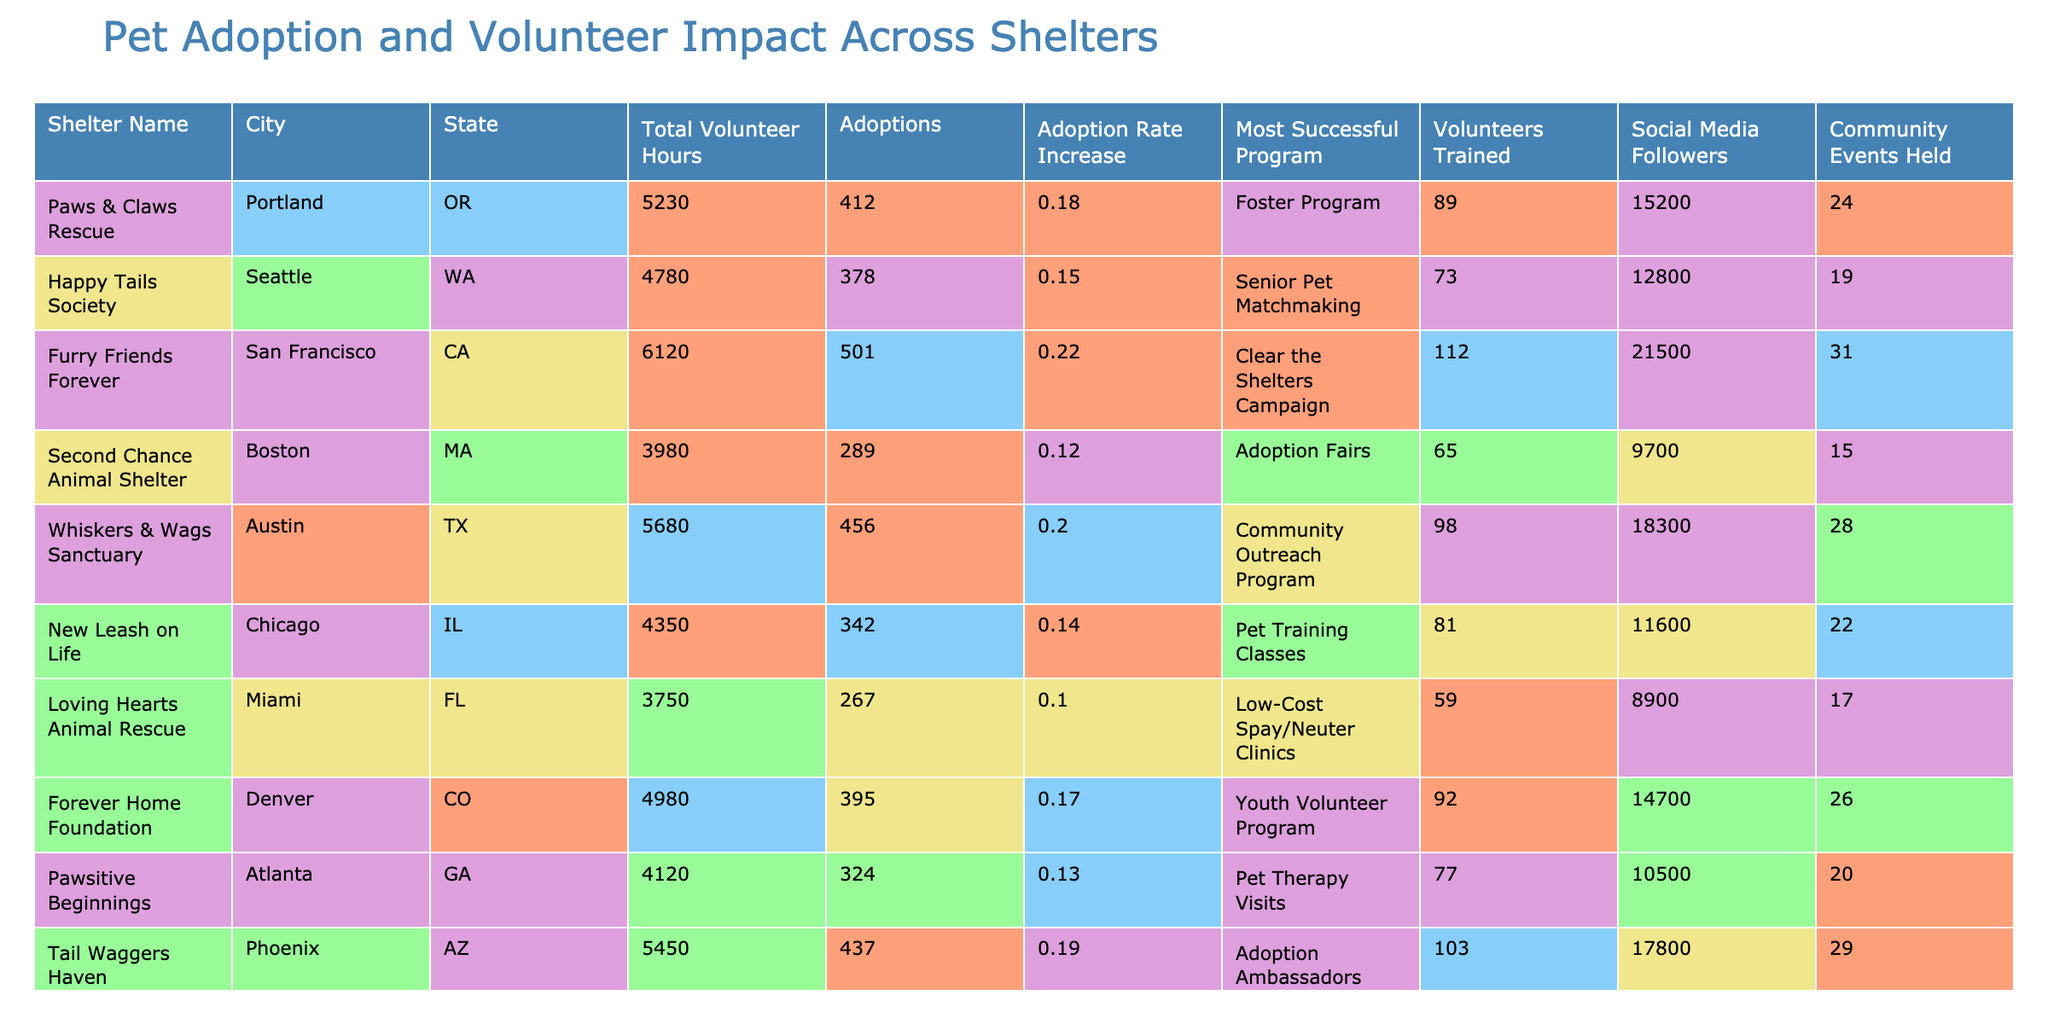What is the total number of volunteer hours contributed by Paws & Claws Rescue? The table shows that the total volunteer hours for Paws & Claws Rescue listed in the relevant column is 5230.
Answer: 5230 Which shelter had the highest adoption rate increase? By examining the "Adoption Rate Increase" column, Furry Friends Forever shows an increase of 22%, which is the highest among all shelters.
Answer: Furry Friends Forever How many adoptions were recorded by Whiskers & Wags Sanctuary? The "Adoptions" column indicates that Whiskers & Wags Sanctuary had 456 adoptions.
Answer: 456 What is the average number of community events held across all shelters? First, we sum the community events: 24 + 19 + 31 + 15 + 28 + 22 + 17 + 26 + 20 + 29 =  241. Then, we divide by the number of shelters (10) to find the average: 241 / 10 = 24.1.
Answer: 24.1 Does Loving Hearts Animal Rescue have more training volunteers than Tail Waggers Haven? Looking at the "Volunteers Trained" column, Loving Hearts has 59 while Tail Waggers has 103; thus, Loving Hearts has fewer volunteers trained.
Answer: No Which city has the shelter that hosted the most community events? In the "Community Events Held" column, Furry Friends Forever in San Francisco held the most events at 31.
Answer: San Francisco What is the difference in adoptions between Paws & Claws Rescue and New Leash on Life? The adoptions for Paws & Claws Rescue are 412 and for New Leash on Life they are 342. The difference is calculated as 412 - 342 = 70.
Answer: 70 Is it true that the majority of the shelters have more than 400 social media followers? Checking the "Social Media Followers" column, all shelters have follower counts (from 8900 to 21500) which exceed 400, confirming this statement as true.
Answer: Yes How many more total volunteer hours did Furry Friends Forever contribute compared to Loving Hearts Animal Rescue? Furry Friends Forever contributed 6120 hours, while Loving Hearts contributed 3750 hours. The difference is 6120 - 3750 = 2370.
Answer: 2370 Which program was the most successful at Happy Tails Society? The table states that the most successful program for Happy Tails Society is "Senior Pet Matchmaking."
Answer: Senior Pet Matchmaking 